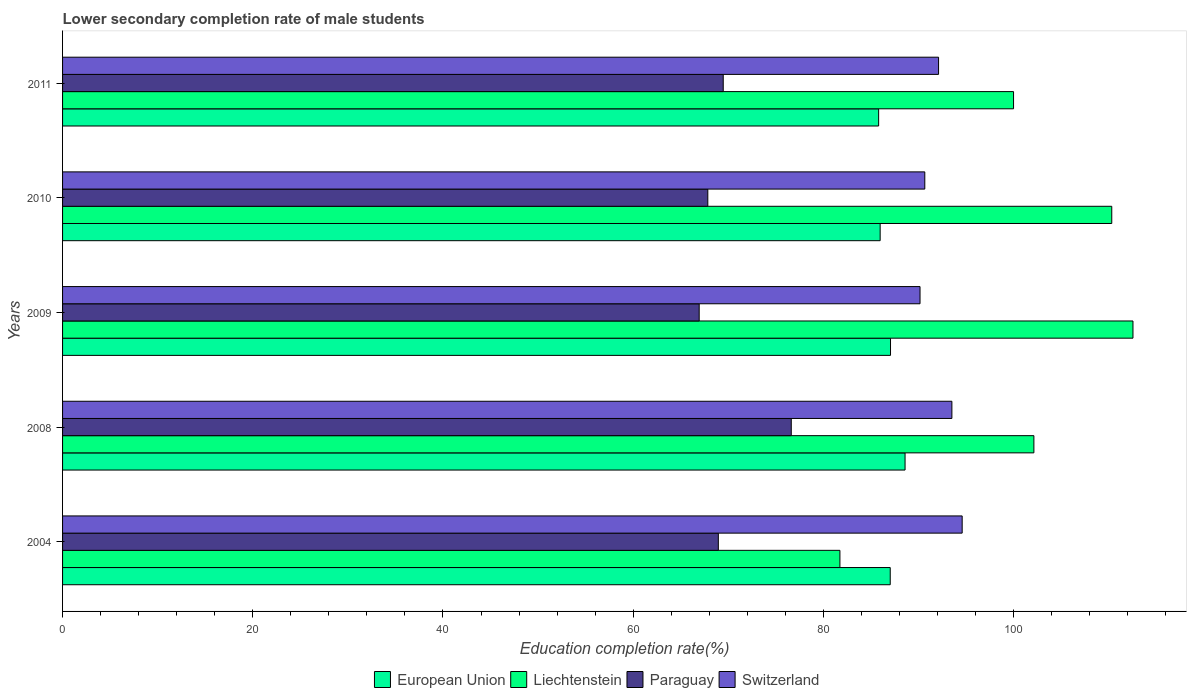Are the number of bars per tick equal to the number of legend labels?
Offer a very short reply. Yes. How many bars are there on the 2nd tick from the top?
Provide a succinct answer. 4. What is the label of the 4th group of bars from the top?
Ensure brevity in your answer.  2008. What is the lower secondary completion rate of male students in Paraguay in 2011?
Provide a succinct answer. 69.47. Across all years, what is the maximum lower secondary completion rate of male students in Liechtenstein?
Provide a short and direct response. 112.56. Across all years, what is the minimum lower secondary completion rate of male students in Paraguay?
Provide a succinct answer. 66.94. What is the total lower secondary completion rate of male students in Switzerland in the graph?
Make the answer very short. 461.06. What is the difference between the lower secondary completion rate of male students in Switzerland in 2008 and that in 2011?
Keep it short and to the point. 1.4. What is the difference between the lower secondary completion rate of male students in Paraguay in 2010 and the lower secondary completion rate of male students in European Union in 2008?
Keep it short and to the point. -20.74. What is the average lower secondary completion rate of male students in Paraguay per year?
Your response must be concise. 69.97. In the year 2008, what is the difference between the lower secondary completion rate of male students in Liechtenstein and lower secondary completion rate of male students in European Union?
Offer a very short reply. 13.55. What is the ratio of the lower secondary completion rate of male students in European Union in 2004 to that in 2009?
Make the answer very short. 1. Is the lower secondary completion rate of male students in Paraguay in 2009 less than that in 2010?
Your answer should be very brief. Yes. What is the difference between the highest and the second highest lower secondary completion rate of male students in Switzerland?
Your response must be concise. 1.08. What is the difference between the highest and the lowest lower secondary completion rate of male students in Switzerland?
Keep it short and to the point. 4.43. In how many years, is the lower secondary completion rate of male students in Switzerland greater than the average lower secondary completion rate of male students in Switzerland taken over all years?
Ensure brevity in your answer.  2. What does the 1st bar from the top in 2008 represents?
Offer a terse response. Switzerland. What does the 3rd bar from the bottom in 2010 represents?
Make the answer very short. Paraguay. How many bars are there?
Offer a terse response. 20. Are all the bars in the graph horizontal?
Provide a short and direct response. Yes. Does the graph contain grids?
Make the answer very short. No. What is the title of the graph?
Provide a succinct answer. Lower secondary completion rate of male students. What is the label or title of the X-axis?
Give a very brief answer. Education completion rate(%). What is the label or title of the Y-axis?
Offer a terse response. Years. What is the Education completion rate(%) in European Union in 2004?
Keep it short and to the point. 87.03. What is the Education completion rate(%) in Liechtenstein in 2004?
Your response must be concise. 81.74. What is the Education completion rate(%) of Paraguay in 2004?
Keep it short and to the point. 68.96. What is the Education completion rate(%) in Switzerland in 2004?
Make the answer very short. 94.6. What is the Education completion rate(%) in European Union in 2008?
Your answer should be very brief. 88.59. What is the Education completion rate(%) in Liechtenstein in 2008?
Provide a short and direct response. 102.14. What is the Education completion rate(%) of Paraguay in 2008?
Make the answer very short. 76.63. What is the Education completion rate(%) in Switzerland in 2008?
Give a very brief answer. 93.52. What is the Education completion rate(%) in European Union in 2009?
Ensure brevity in your answer.  87.06. What is the Education completion rate(%) in Liechtenstein in 2009?
Offer a very short reply. 112.56. What is the Education completion rate(%) of Paraguay in 2009?
Make the answer very short. 66.94. What is the Education completion rate(%) of Switzerland in 2009?
Make the answer very short. 90.17. What is the Education completion rate(%) of European Union in 2010?
Your answer should be compact. 85.97. What is the Education completion rate(%) in Liechtenstein in 2010?
Your answer should be compact. 110.33. What is the Education completion rate(%) in Paraguay in 2010?
Give a very brief answer. 67.85. What is the Education completion rate(%) in Switzerland in 2010?
Your response must be concise. 90.67. What is the Education completion rate(%) of European Union in 2011?
Your answer should be very brief. 85.81. What is the Education completion rate(%) of Paraguay in 2011?
Ensure brevity in your answer.  69.47. What is the Education completion rate(%) in Switzerland in 2011?
Your response must be concise. 92.12. Across all years, what is the maximum Education completion rate(%) in European Union?
Give a very brief answer. 88.59. Across all years, what is the maximum Education completion rate(%) in Liechtenstein?
Offer a very short reply. 112.56. Across all years, what is the maximum Education completion rate(%) in Paraguay?
Provide a short and direct response. 76.63. Across all years, what is the maximum Education completion rate(%) of Switzerland?
Keep it short and to the point. 94.6. Across all years, what is the minimum Education completion rate(%) of European Union?
Offer a terse response. 85.81. Across all years, what is the minimum Education completion rate(%) of Liechtenstein?
Your response must be concise. 81.74. Across all years, what is the minimum Education completion rate(%) in Paraguay?
Your answer should be very brief. 66.94. Across all years, what is the minimum Education completion rate(%) in Switzerland?
Give a very brief answer. 90.17. What is the total Education completion rate(%) of European Union in the graph?
Provide a short and direct response. 434.48. What is the total Education completion rate(%) in Liechtenstein in the graph?
Your response must be concise. 506.77. What is the total Education completion rate(%) of Paraguay in the graph?
Provide a short and direct response. 349.85. What is the total Education completion rate(%) in Switzerland in the graph?
Make the answer very short. 461.06. What is the difference between the Education completion rate(%) in European Union in 2004 and that in 2008?
Your answer should be compact. -1.56. What is the difference between the Education completion rate(%) of Liechtenstein in 2004 and that in 2008?
Your response must be concise. -20.4. What is the difference between the Education completion rate(%) in Paraguay in 2004 and that in 2008?
Your answer should be very brief. -7.67. What is the difference between the Education completion rate(%) of Switzerland in 2004 and that in 2008?
Your answer should be compact. 1.08. What is the difference between the Education completion rate(%) in European Union in 2004 and that in 2009?
Your answer should be compact. -0.03. What is the difference between the Education completion rate(%) of Liechtenstein in 2004 and that in 2009?
Provide a succinct answer. -30.82. What is the difference between the Education completion rate(%) in Paraguay in 2004 and that in 2009?
Your answer should be compact. 2.01. What is the difference between the Education completion rate(%) in Switzerland in 2004 and that in 2009?
Provide a short and direct response. 4.43. What is the difference between the Education completion rate(%) in European Union in 2004 and that in 2010?
Offer a very short reply. 1.06. What is the difference between the Education completion rate(%) in Liechtenstein in 2004 and that in 2010?
Your answer should be compact. -28.59. What is the difference between the Education completion rate(%) in Paraguay in 2004 and that in 2010?
Your answer should be very brief. 1.11. What is the difference between the Education completion rate(%) in Switzerland in 2004 and that in 2010?
Keep it short and to the point. 3.93. What is the difference between the Education completion rate(%) in European Union in 2004 and that in 2011?
Keep it short and to the point. 1.22. What is the difference between the Education completion rate(%) in Liechtenstein in 2004 and that in 2011?
Your answer should be compact. -18.26. What is the difference between the Education completion rate(%) of Paraguay in 2004 and that in 2011?
Give a very brief answer. -0.51. What is the difference between the Education completion rate(%) of Switzerland in 2004 and that in 2011?
Ensure brevity in your answer.  2.48. What is the difference between the Education completion rate(%) in European Union in 2008 and that in 2009?
Keep it short and to the point. 1.53. What is the difference between the Education completion rate(%) in Liechtenstein in 2008 and that in 2009?
Make the answer very short. -10.42. What is the difference between the Education completion rate(%) in Paraguay in 2008 and that in 2009?
Your answer should be very brief. 9.68. What is the difference between the Education completion rate(%) of Switzerland in 2008 and that in 2009?
Give a very brief answer. 3.35. What is the difference between the Education completion rate(%) in European Union in 2008 and that in 2010?
Make the answer very short. 2.62. What is the difference between the Education completion rate(%) of Liechtenstein in 2008 and that in 2010?
Provide a short and direct response. -8.19. What is the difference between the Education completion rate(%) in Paraguay in 2008 and that in 2010?
Offer a terse response. 8.78. What is the difference between the Education completion rate(%) in Switzerland in 2008 and that in 2010?
Keep it short and to the point. 2.85. What is the difference between the Education completion rate(%) of European Union in 2008 and that in 2011?
Ensure brevity in your answer.  2.78. What is the difference between the Education completion rate(%) of Liechtenstein in 2008 and that in 2011?
Your answer should be very brief. 2.14. What is the difference between the Education completion rate(%) of Paraguay in 2008 and that in 2011?
Your answer should be compact. 7.15. What is the difference between the Education completion rate(%) of Switzerland in 2008 and that in 2011?
Provide a succinct answer. 1.4. What is the difference between the Education completion rate(%) of European Union in 2009 and that in 2010?
Offer a very short reply. 1.09. What is the difference between the Education completion rate(%) of Liechtenstein in 2009 and that in 2010?
Your answer should be compact. 2.23. What is the difference between the Education completion rate(%) in Paraguay in 2009 and that in 2010?
Your answer should be compact. -0.91. What is the difference between the Education completion rate(%) of Switzerland in 2009 and that in 2010?
Provide a short and direct response. -0.5. What is the difference between the Education completion rate(%) of European Union in 2009 and that in 2011?
Keep it short and to the point. 1.25. What is the difference between the Education completion rate(%) in Liechtenstein in 2009 and that in 2011?
Your answer should be compact. 12.56. What is the difference between the Education completion rate(%) in Paraguay in 2009 and that in 2011?
Ensure brevity in your answer.  -2.53. What is the difference between the Education completion rate(%) of Switzerland in 2009 and that in 2011?
Ensure brevity in your answer.  -1.95. What is the difference between the Education completion rate(%) in European Union in 2010 and that in 2011?
Make the answer very short. 0.16. What is the difference between the Education completion rate(%) of Liechtenstein in 2010 and that in 2011?
Keep it short and to the point. 10.33. What is the difference between the Education completion rate(%) in Paraguay in 2010 and that in 2011?
Give a very brief answer. -1.62. What is the difference between the Education completion rate(%) in Switzerland in 2010 and that in 2011?
Your answer should be compact. -1.45. What is the difference between the Education completion rate(%) in European Union in 2004 and the Education completion rate(%) in Liechtenstein in 2008?
Keep it short and to the point. -15.11. What is the difference between the Education completion rate(%) in European Union in 2004 and the Education completion rate(%) in Paraguay in 2008?
Make the answer very short. 10.41. What is the difference between the Education completion rate(%) in European Union in 2004 and the Education completion rate(%) in Switzerland in 2008?
Offer a terse response. -6.48. What is the difference between the Education completion rate(%) of Liechtenstein in 2004 and the Education completion rate(%) of Paraguay in 2008?
Keep it short and to the point. 5.12. What is the difference between the Education completion rate(%) in Liechtenstein in 2004 and the Education completion rate(%) in Switzerland in 2008?
Your answer should be very brief. -11.77. What is the difference between the Education completion rate(%) of Paraguay in 2004 and the Education completion rate(%) of Switzerland in 2008?
Your answer should be very brief. -24.56. What is the difference between the Education completion rate(%) in European Union in 2004 and the Education completion rate(%) in Liechtenstein in 2009?
Your answer should be compact. -25.52. What is the difference between the Education completion rate(%) of European Union in 2004 and the Education completion rate(%) of Paraguay in 2009?
Keep it short and to the point. 20.09. What is the difference between the Education completion rate(%) of European Union in 2004 and the Education completion rate(%) of Switzerland in 2009?
Make the answer very short. -3.13. What is the difference between the Education completion rate(%) of Liechtenstein in 2004 and the Education completion rate(%) of Paraguay in 2009?
Your answer should be very brief. 14.8. What is the difference between the Education completion rate(%) of Liechtenstein in 2004 and the Education completion rate(%) of Switzerland in 2009?
Make the answer very short. -8.42. What is the difference between the Education completion rate(%) in Paraguay in 2004 and the Education completion rate(%) in Switzerland in 2009?
Your answer should be compact. -21.21. What is the difference between the Education completion rate(%) of European Union in 2004 and the Education completion rate(%) of Liechtenstein in 2010?
Keep it short and to the point. -23.3. What is the difference between the Education completion rate(%) in European Union in 2004 and the Education completion rate(%) in Paraguay in 2010?
Your response must be concise. 19.18. What is the difference between the Education completion rate(%) in European Union in 2004 and the Education completion rate(%) in Switzerland in 2010?
Provide a succinct answer. -3.63. What is the difference between the Education completion rate(%) in Liechtenstein in 2004 and the Education completion rate(%) in Paraguay in 2010?
Provide a short and direct response. 13.89. What is the difference between the Education completion rate(%) of Liechtenstein in 2004 and the Education completion rate(%) of Switzerland in 2010?
Give a very brief answer. -8.93. What is the difference between the Education completion rate(%) of Paraguay in 2004 and the Education completion rate(%) of Switzerland in 2010?
Give a very brief answer. -21.71. What is the difference between the Education completion rate(%) in European Union in 2004 and the Education completion rate(%) in Liechtenstein in 2011?
Your answer should be compact. -12.97. What is the difference between the Education completion rate(%) in European Union in 2004 and the Education completion rate(%) in Paraguay in 2011?
Provide a short and direct response. 17.56. What is the difference between the Education completion rate(%) in European Union in 2004 and the Education completion rate(%) in Switzerland in 2011?
Provide a succinct answer. -5.08. What is the difference between the Education completion rate(%) of Liechtenstein in 2004 and the Education completion rate(%) of Paraguay in 2011?
Ensure brevity in your answer.  12.27. What is the difference between the Education completion rate(%) in Liechtenstein in 2004 and the Education completion rate(%) in Switzerland in 2011?
Provide a short and direct response. -10.37. What is the difference between the Education completion rate(%) of Paraguay in 2004 and the Education completion rate(%) of Switzerland in 2011?
Provide a succinct answer. -23.16. What is the difference between the Education completion rate(%) in European Union in 2008 and the Education completion rate(%) in Liechtenstein in 2009?
Ensure brevity in your answer.  -23.97. What is the difference between the Education completion rate(%) of European Union in 2008 and the Education completion rate(%) of Paraguay in 2009?
Give a very brief answer. 21.65. What is the difference between the Education completion rate(%) of European Union in 2008 and the Education completion rate(%) of Switzerland in 2009?
Ensure brevity in your answer.  -1.57. What is the difference between the Education completion rate(%) of Liechtenstein in 2008 and the Education completion rate(%) of Paraguay in 2009?
Make the answer very short. 35.2. What is the difference between the Education completion rate(%) in Liechtenstein in 2008 and the Education completion rate(%) in Switzerland in 2009?
Provide a succinct answer. 11.97. What is the difference between the Education completion rate(%) in Paraguay in 2008 and the Education completion rate(%) in Switzerland in 2009?
Keep it short and to the point. -13.54. What is the difference between the Education completion rate(%) in European Union in 2008 and the Education completion rate(%) in Liechtenstein in 2010?
Offer a very short reply. -21.74. What is the difference between the Education completion rate(%) in European Union in 2008 and the Education completion rate(%) in Paraguay in 2010?
Your answer should be very brief. 20.74. What is the difference between the Education completion rate(%) in European Union in 2008 and the Education completion rate(%) in Switzerland in 2010?
Provide a short and direct response. -2.07. What is the difference between the Education completion rate(%) in Liechtenstein in 2008 and the Education completion rate(%) in Paraguay in 2010?
Provide a short and direct response. 34.29. What is the difference between the Education completion rate(%) of Liechtenstein in 2008 and the Education completion rate(%) of Switzerland in 2010?
Offer a terse response. 11.47. What is the difference between the Education completion rate(%) in Paraguay in 2008 and the Education completion rate(%) in Switzerland in 2010?
Provide a succinct answer. -14.04. What is the difference between the Education completion rate(%) of European Union in 2008 and the Education completion rate(%) of Liechtenstein in 2011?
Your answer should be very brief. -11.41. What is the difference between the Education completion rate(%) of European Union in 2008 and the Education completion rate(%) of Paraguay in 2011?
Keep it short and to the point. 19.12. What is the difference between the Education completion rate(%) in European Union in 2008 and the Education completion rate(%) in Switzerland in 2011?
Make the answer very short. -3.52. What is the difference between the Education completion rate(%) of Liechtenstein in 2008 and the Education completion rate(%) of Paraguay in 2011?
Give a very brief answer. 32.67. What is the difference between the Education completion rate(%) in Liechtenstein in 2008 and the Education completion rate(%) in Switzerland in 2011?
Ensure brevity in your answer.  10.02. What is the difference between the Education completion rate(%) in Paraguay in 2008 and the Education completion rate(%) in Switzerland in 2011?
Your answer should be very brief. -15.49. What is the difference between the Education completion rate(%) of European Union in 2009 and the Education completion rate(%) of Liechtenstein in 2010?
Give a very brief answer. -23.27. What is the difference between the Education completion rate(%) in European Union in 2009 and the Education completion rate(%) in Paraguay in 2010?
Keep it short and to the point. 19.21. What is the difference between the Education completion rate(%) in European Union in 2009 and the Education completion rate(%) in Switzerland in 2010?
Provide a short and direct response. -3.61. What is the difference between the Education completion rate(%) in Liechtenstein in 2009 and the Education completion rate(%) in Paraguay in 2010?
Keep it short and to the point. 44.71. What is the difference between the Education completion rate(%) in Liechtenstein in 2009 and the Education completion rate(%) in Switzerland in 2010?
Offer a terse response. 21.89. What is the difference between the Education completion rate(%) in Paraguay in 2009 and the Education completion rate(%) in Switzerland in 2010?
Offer a very short reply. -23.72. What is the difference between the Education completion rate(%) in European Union in 2009 and the Education completion rate(%) in Liechtenstein in 2011?
Make the answer very short. -12.94. What is the difference between the Education completion rate(%) in European Union in 2009 and the Education completion rate(%) in Paraguay in 2011?
Ensure brevity in your answer.  17.59. What is the difference between the Education completion rate(%) of European Union in 2009 and the Education completion rate(%) of Switzerland in 2011?
Keep it short and to the point. -5.05. What is the difference between the Education completion rate(%) in Liechtenstein in 2009 and the Education completion rate(%) in Paraguay in 2011?
Keep it short and to the point. 43.09. What is the difference between the Education completion rate(%) of Liechtenstein in 2009 and the Education completion rate(%) of Switzerland in 2011?
Provide a succinct answer. 20.44. What is the difference between the Education completion rate(%) in Paraguay in 2009 and the Education completion rate(%) in Switzerland in 2011?
Your answer should be very brief. -25.17. What is the difference between the Education completion rate(%) in European Union in 2010 and the Education completion rate(%) in Liechtenstein in 2011?
Ensure brevity in your answer.  -14.03. What is the difference between the Education completion rate(%) of European Union in 2010 and the Education completion rate(%) of Paraguay in 2011?
Your response must be concise. 16.5. What is the difference between the Education completion rate(%) of European Union in 2010 and the Education completion rate(%) of Switzerland in 2011?
Your answer should be compact. -6.14. What is the difference between the Education completion rate(%) in Liechtenstein in 2010 and the Education completion rate(%) in Paraguay in 2011?
Your response must be concise. 40.86. What is the difference between the Education completion rate(%) in Liechtenstein in 2010 and the Education completion rate(%) in Switzerland in 2011?
Provide a succinct answer. 18.21. What is the difference between the Education completion rate(%) of Paraguay in 2010 and the Education completion rate(%) of Switzerland in 2011?
Make the answer very short. -24.27. What is the average Education completion rate(%) of European Union per year?
Your response must be concise. 86.9. What is the average Education completion rate(%) of Liechtenstein per year?
Offer a very short reply. 101.35. What is the average Education completion rate(%) in Paraguay per year?
Make the answer very short. 69.97. What is the average Education completion rate(%) in Switzerland per year?
Keep it short and to the point. 92.21. In the year 2004, what is the difference between the Education completion rate(%) of European Union and Education completion rate(%) of Liechtenstein?
Your answer should be compact. 5.29. In the year 2004, what is the difference between the Education completion rate(%) in European Union and Education completion rate(%) in Paraguay?
Your response must be concise. 18.08. In the year 2004, what is the difference between the Education completion rate(%) in European Union and Education completion rate(%) in Switzerland?
Make the answer very short. -7.56. In the year 2004, what is the difference between the Education completion rate(%) of Liechtenstein and Education completion rate(%) of Paraguay?
Your response must be concise. 12.79. In the year 2004, what is the difference between the Education completion rate(%) in Liechtenstein and Education completion rate(%) in Switzerland?
Your response must be concise. -12.86. In the year 2004, what is the difference between the Education completion rate(%) of Paraguay and Education completion rate(%) of Switzerland?
Ensure brevity in your answer.  -25.64. In the year 2008, what is the difference between the Education completion rate(%) in European Union and Education completion rate(%) in Liechtenstein?
Offer a terse response. -13.55. In the year 2008, what is the difference between the Education completion rate(%) in European Union and Education completion rate(%) in Paraguay?
Your response must be concise. 11.97. In the year 2008, what is the difference between the Education completion rate(%) in European Union and Education completion rate(%) in Switzerland?
Ensure brevity in your answer.  -4.92. In the year 2008, what is the difference between the Education completion rate(%) in Liechtenstein and Education completion rate(%) in Paraguay?
Offer a very short reply. 25.51. In the year 2008, what is the difference between the Education completion rate(%) in Liechtenstein and Education completion rate(%) in Switzerland?
Your answer should be compact. 8.62. In the year 2008, what is the difference between the Education completion rate(%) of Paraguay and Education completion rate(%) of Switzerland?
Provide a succinct answer. -16.89. In the year 2009, what is the difference between the Education completion rate(%) in European Union and Education completion rate(%) in Liechtenstein?
Your response must be concise. -25.5. In the year 2009, what is the difference between the Education completion rate(%) in European Union and Education completion rate(%) in Paraguay?
Keep it short and to the point. 20.12. In the year 2009, what is the difference between the Education completion rate(%) in European Union and Education completion rate(%) in Switzerland?
Offer a terse response. -3.1. In the year 2009, what is the difference between the Education completion rate(%) of Liechtenstein and Education completion rate(%) of Paraguay?
Keep it short and to the point. 45.61. In the year 2009, what is the difference between the Education completion rate(%) of Liechtenstein and Education completion rate(%) of Switzerland?
Your answer should be compact. 22.39. In the year 2009, what is the difference between the Education completion rate(%) of Paraguay and Education completion rate(%) of Switzerland?
Provide a short and direct response. -23.22. In the year 2010, what is the difference between the Education completion rate(%) in European Union and Education completion rate(%) in Liechtenstein?
Provide a succinct answer. -24.35. In the year 2010, what is the difference between the Education completion rate(%) in European Union and Education completion rate(%) in Paraguay?
Offer a terse response. 18.12. In the year 2010, what is the difference between the Education completion rate(%) in European Union and Education completion rate(%) in Switzerland?
Give a very brief answer. -4.69. In the year 2010, what is the difference between the Education completion rate(%) of Liechtenstein and Education completion rate(%) of Paraguay?
Offer a terse response. 42.48. In the year 2010, what is the difference between the Education completion rate(%) in Liechtenstein and Education completion rate(%) in Switzerland?
Your answer should be compact. 19.66. In the year 2010, what is the difference between the Education completion rate(%) of Paraguay and Education completion rate(%) of Switzerland?
Ensure brevity in your answer.  -22.82. In the year 2011, what is the difference between the Education completion rate(%) of European Union and Education completion rate(%) of Liechtenstein?
Your response must be concise. -14.19. In the year 2011, what is the difference between the Education completion rate(%) of European Union and Education completion rate(%) of Paraguay?
Ensure brevity in your answer.  16.34. In the year 2011, what is the difference between the Education completion rate(%) of European Union and Education completion rate(%) of Switzerland?
Ensure brevity in your answer.  -6.3. In the year 2011, what is the difference between the Education completion rate(%) of Liechtenstein and Education completion rate(%) of Paraguay?
Offer a terse response. 30.53. In the year 2011, what is the difference between the Education completion rate(%) of Liechtenstein and Education completion rate(%) of Switzerland?
Your response must be concise. 7.88. In the year 2011, what is the difference between the Education completion rate(%) in Paraguay and Education completion rate(%) in Switzerland?
Offer a terse response. -22.64. What is the ratio of the Education completion rate(%) in European Union in 2004 to that in 2008?
Give a very brief answer. 0.98. What is the ratio of the Education completion rate(%) of Liechtenstein in 2004 to that in 2008?
Provide a succinct answer. 0.8. What is the ratio of the Education completion rate(%) in Paraguay in 2004 to that in 2008?
Your response must be concise. 0.9. What is the ratio of the Education completion rate(%) in Switzerland in 2004 to that in 2008?
Your response must be concise. 1.01. What is the ratio of the Education completion rate(%) of Liechtenstein in 2004 to that in 2009?
Your answer should be very brief. 0.73. What is the ratio of the Education completion rate(%) in Paraguay in 2004 to that in 2009?
Provide a succinct answer. 1.03. What is the ratio of the Education completion rate(%) in Switzerland in 2004 to that in 2009?
Your answer should be very brief. 1.05. What is the ratio of the Education completion rate(%) in European Union in 2004 to that in 2010?
Your answer should be very brief. 1.01. What is the ratio of the Education completion rate(%) of Liechtenstein in 2004 to that in 2010?
Your response must be concise. 0.74. What is the ratio of the Education completion rate(%) of Paraguay in 2004 to that in 2010?
Offer a very short reply. 1.02. What is the ratio of the Education completion rate(%) in Switzerland in 2004 to that in 2010?
Give a very brief answer. 1.04. What is the ratio of the Education completion rate(%) of European Union in 2004 to that in 2011?
Keep it short and to the point. 1.01. What is the ratio of the Education completion rate(%) of Liechtenstein in 2004 to that in 2011?
Offer a very short reply. 0.82. What is the ratio of the Education completion rate(%) in Paraguay in 2004 to that in 2011?
Offer a very short reply. 0.99. What is the ratio of the Education completion rate(%) of Switzerland in 2004 to that in 2011?
Make the answer very short. 1.03. What is the ratio of the Education completion rate(%) of European Union in 2008 to that in 2009?
Provide a succinct answer. 1.02. What is the ratio of the Education completion rate(%) of Liechtenstein in 2008 to that in 2009?
Make the answer very short. 0.91. What is the ratio of the Education completion rate(%) in Paraguay in 2008 to that in 2009?
Your response must be concise. 1.14. What is the ratio of the Education completion rate(%) of Switzerland in 2008 to that in 2009?
Give a very brief answer. 1.04. What is the ratio of the Education completion rate(%) of European Union in 2008 to that in 2010?
Provide a succinct answer. 1.03. What is the ratio of the Education completion rate(%) of Liechtenstein in 2008 to that in 2010?
Offer a terse response. 0.93. What is the ratio of the Education completion rate(%) in Paraguay in 2008 to that in 2010?
Provide a short and direct response. 1.13. What is the ratio of the Education completion rate(%) of Switzerland in 2008 to that in 2010?
Keep it short and to the point. 1.03. What is the ratio of the Education completion rate(%) of European Union in 2008 to that in 2011?
Offer a terse response. 1.03. What is the ratio of the Education completion rate(%) of Liechtenstein in 2008 to that in 2011?
Offer a terse response. 1.02. What is the ratio of the Education completion rate(%) of Paraguay in 2008 to that in 2011?
Make the answer very short. 1.1. What is the ratio of the Education completion rate(%) of Switzerland in 2008 to that in 2011?
Provide a short and direct response. 1.02. What is the ratio of the Education completion rate(%) in European Union in 2009 to that in 2010?
Provide a succinct answer. 1.01. What is the ratio of the Education completion rate(%) of Liechtenstein in 2009 to that in 2010?
Offer a very short reply. 1.02. What is the ratio of the Education completion rate(%) of Paraguay in 2009 to that in 2010?
Provide a short and direct response. 0.99. What is the ratio of the Education completion rate(%) of Switzerland in 2009 to that in 2010?
Offer a terse response. 0.99. What is the ratio of the Education completion rate(%) in European Union in 2009 to that in 2011?
Offer a terse response. 1.01. What is the ratio of the Education completion rate(%) in Liechtenstein in 2009 to that in 2011?
Offer a very short reply. 1.13. What is the ratio of the Education completion rate(%) in Paraguay in 2009 to that in 2011?
Offer a terse response. 0.96. What is the ratio of the Education completion rate(%) of Switzerland in 2009 to that in 2011?
Your answer should be very brief. 0.98. What is the ratio of the Education completion rate(%) in European Union in 2010 to that in 2011?
Provide a short and direct response. 1. What is the ratio of the Education completion rate(%) of Liechtenstein in 2010 to that in 2011?
Give a very brief answer. 1.1. What is the ratio of the Education completion rate(%) of Paraguay in 2010 to that in 2011?
Your answer should be very brief. 0.98. What is the ratio of the Education completion rate(%) of Switzerland in 2010 to that in 2011?
Make the answer very short. 0.98. What is the difference between the highest and the second highest Education completion rate(%) in European Union?
Ensure brevity in your answer.  1.53. What is the difference between the highest and the second highest Education completion rate(%) of Liechtenstein?
Offer a very short reply. 2.23. What is the difference between the highest and the second highest Education completion rate(%) in Paraguay?
Your answer should be compact. 7.15. What is the difference between the highest and the second highest Education completion rate(%) of Switzerland?
Make the answer very short. 1.08. What is the difference between the highest and the lowest Education completion rate(%) of European Union?
Your answer should be very brief. 2.78. What is the difference between the highest and the lowest Education completion rate(%) in Liechtenstein?
Offer a terse response. 30.82. What is the difference between the highest and the lowest Education completion rate(%) in Paraguay?
Your answer should be very brief. 9.68. What is the difference between the highest and the lowest Education completion rate(%) in Switzerland?
Your answer should be compact. 4.43. 